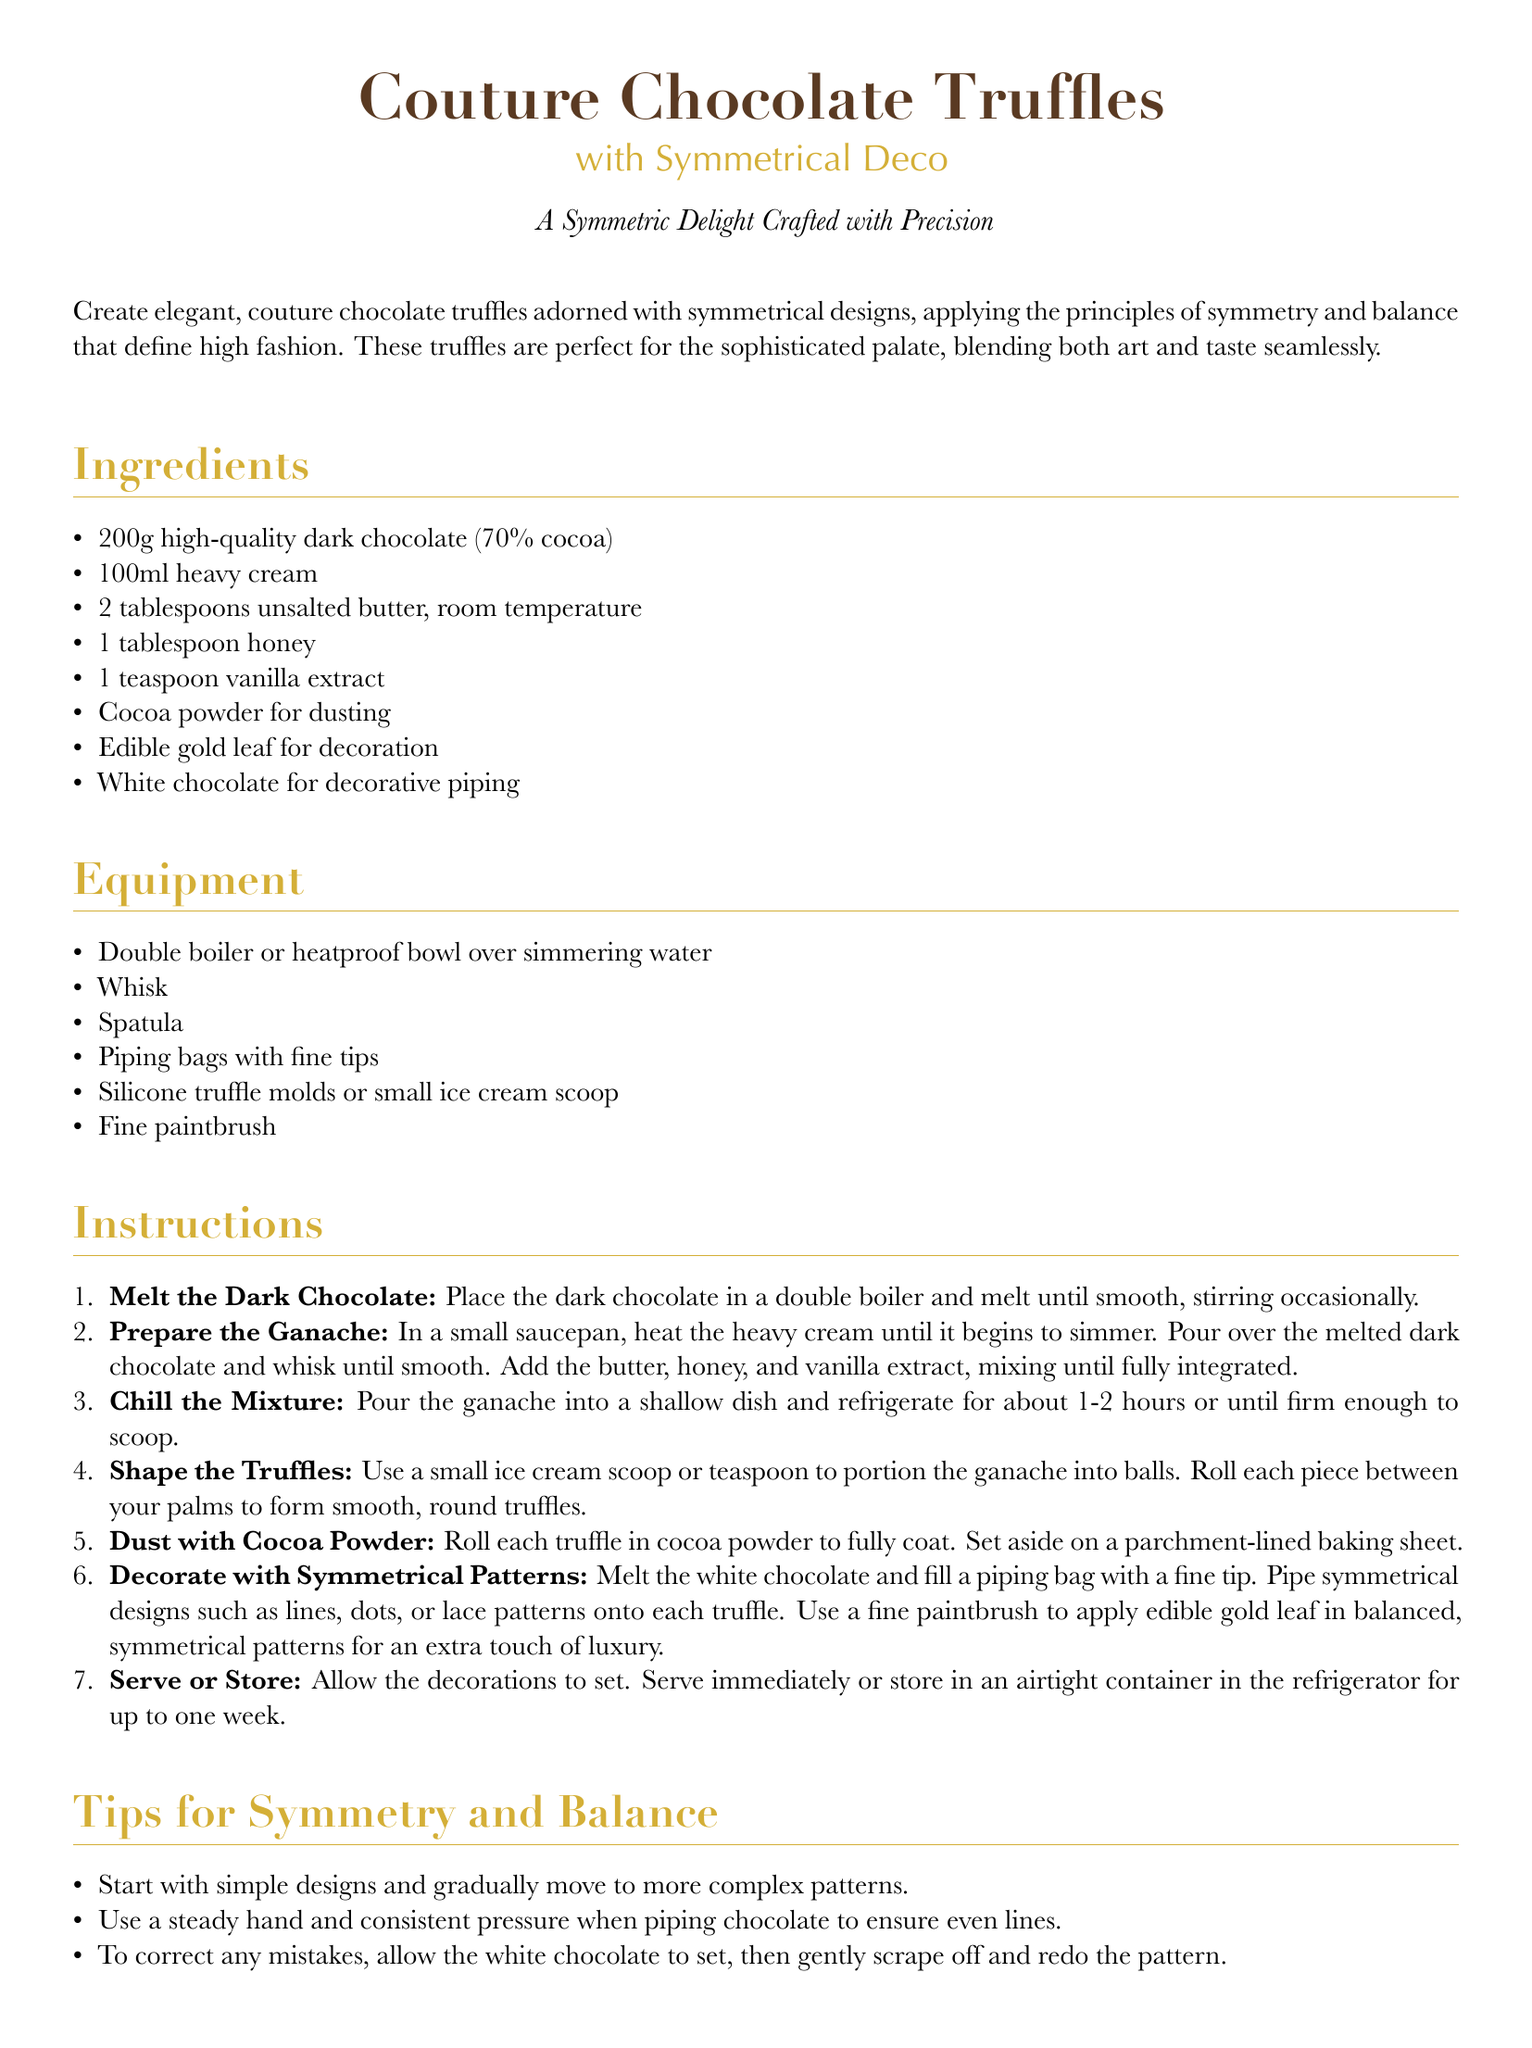What are the main ingredients? The main ingredients are listed under the Ingredients section of the document, which include dark chocolate, cream, butter, honey, vanilla, cocoa powder, gold leaf, and white chocolate.
Answer: Dark chocolate, cream, butter, honey, vanilla, cocoa powder, gold leaf, white chocolate How many grams of dark chocolate are needed? The recipe specifies the amount of dark chocolate required in grams, which is mentioned in the Ingredients section.
Answer: 200g What is used for decoration? The decoration details are provided in the Ingredients section, specifying what to use for decoration.
Answer: Edible gold leaf What is the first step in the instructions? The first step in the Instructions section outlines the initial action to take while making the truffles.
Answer: Melt the Dark Chocolate Which equipment is required for shaping truffles? The necessary equipment for shaping truffles is listed, with a specific mention in the Equipment section.
Answer: Small ice cream scoop What is a tip for creating symmetrical designs? Tips for achieving symmetry in decoration are included in the Tips for Symmetry and Balance section, offering guidance for the piped designs.
Answer: Start with simple designs How long should the ganache chill? The recommended chilling time for the ganache is stated in the Instructions section of the document.
Answer: 1-2 hours What should the truffles be served on? Serving suggestions are provided at the end of the document, highlighting how to present the truffles attractively.
Answer: Mirrored tray What temperature should the heavy cream be heated to? The document describes the necessary condition for heating the cream in the Instructions section, indicating when it is ready to pour over the chocolate.
Answer: Simmering 